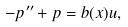<formula> <loc_0><loc_0><loc_500><loc_500>- p ^ { \prime \prime } + p = b ( x ) u ,</formula> 